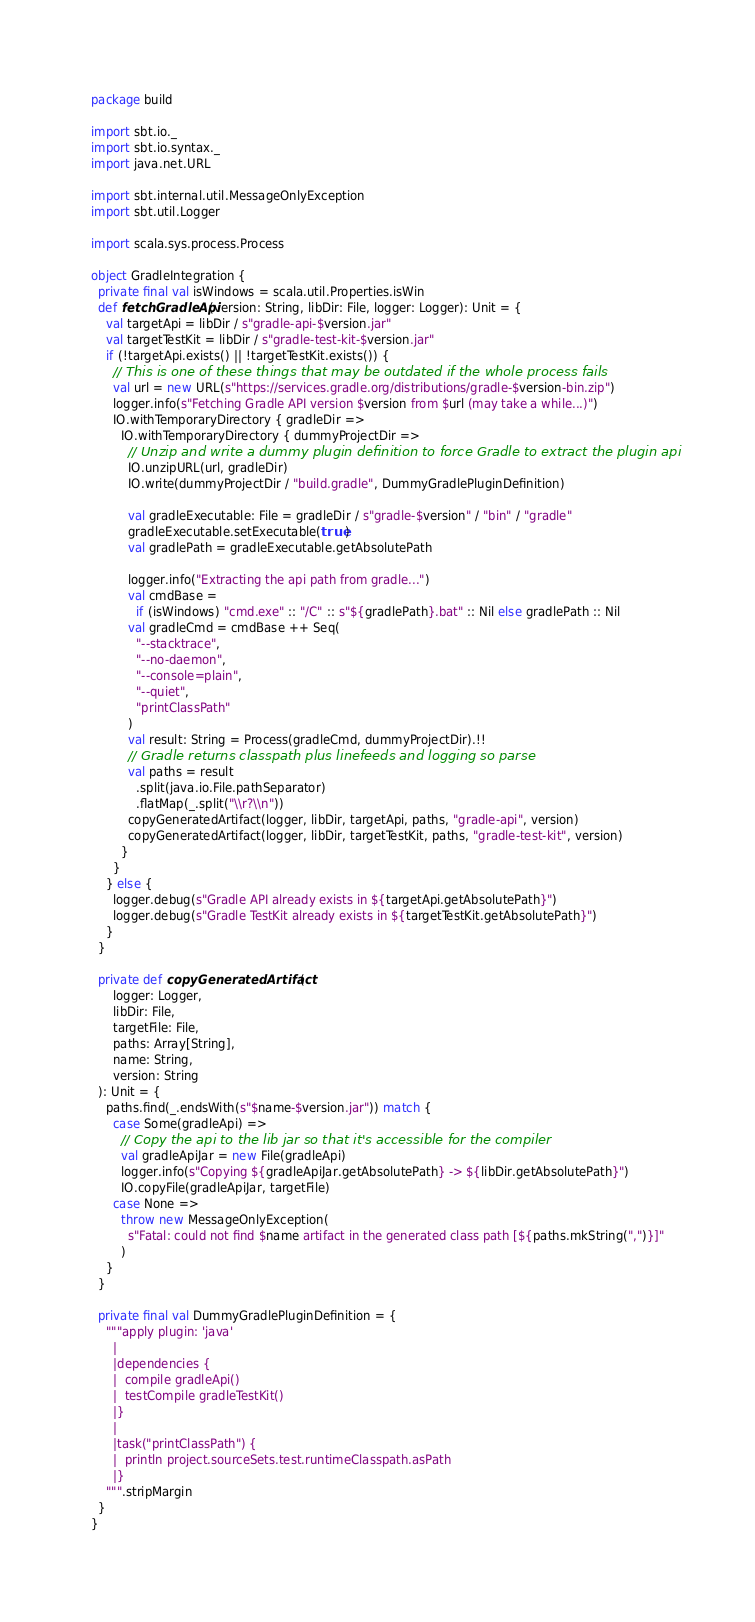Convert code to text. <code><loc_0><loc_0><loc_500><loc_500><_Scala_>package build

import sbt.io._
import sbt.io.syntax._
import java.net.URL

import sbt.internal.util.MessageOnlyException
import sbt.util.Logger

import scala.sys.process.Process

object GradleIntegration {
  private final val isWindows = scala.util.Properties.isWin
  def fetchGradleApi(version: String, libDir: File, logger: Logger): Unit = {
    val targetApi = libDir / s"gradle-api-$version.jar"
    val targetTestKit = libDir / s"gradle-test-kit-$version.jar"
    if (!targetApi.exists() || !targetTestKit.exists()) {
      // This is one of these things that may be outdated if the whole process fails
      val url = new URL(s"https://services.gradle.org/distributions/gradle-$version-bin.zip")
      logger.info(s"Fetching Gradle API version $version from $url (may take a while...)")
      IO.withTemporaryDirectory { gradleDir =>
        IO.withTemporaryDirectory { dummyProjectDir =>
          // Unzip and write a dummy plugin definition to force Gradle to extract the plugin api
          IO.unzipURL(url, gradleDir)
          IO.write(dummyProjectDir / "build.gradle", DummyGradlePluginDefinition)

          val gradleExecutable: File = gradleDir / s"gradle-$version" / "bin" / "gradle"
          gradleExecutable.setExecutable(true)
          val gradlePath = gradleExecutable.getAbsolutePath

          logger.info("Extracting the api path from gradle...")
          val cmdBase =
            if (isWindows) "cmd.exe" :: "/C" :: s"${gradlePath}.bat" :: Nil else gradlePath :: Nil
          val gradleCmd = cmdBase ++ Seq(
            "--stacktrace",
            "--no-daemon",
            "--console=plain",
            "--quiet",
            "printClassPath"
          )
          val result: String = Process(gradleCmd, dummyProjectDir).!!
          // Gradle returns classpath plus linefeeds and logging so parse
          val paths = result
            .split(java.io.File.pathSeparator)
            .flatMap(_.split("\\r?\\n"))
          copyGeneratedArtifact(logger, libDir, targetApi, paths, "gradle-api", version)
          copyGeneratedArtifact(logger, libDir, targetTestKit, paths, "gradle-test-kit", version)
        }
      }
    } else {
      logger.debug(s"Gradle API already exists in ${targetApi.getAbsolutePath}")
      logger.debug(s"Gradle TestKit already exists in ${targetTestKit.getAbsolutePath}")
    }
  }

  private def copyGeneratedArtifact(
      logger: Logger,
      libDir: File,
      targetFile: File,
      paths: Array[String],
      name: String,
      version: String
  ): Unit = {
    paths.find(_.endsWith(s"$name-$version.jar")) match {
      case Some(gradleApi) =>
        // Copy the api to the lib jar so that it's accessible for the compiler
        val gradleApiJar = new File(gradleApi)
        logger.info(s"Copying ${gradleApiJar.getAbsolutePath} -> ${libDir.getAbsolutePath}")
        IO.copyFile(gradleApiJar, targetFile)
      case None =>
        throw new MessageOnlyException(
          s"Fatal: could not find $name artifact in the generated class path [${paths.mkString(",")}]"
        )
    }
  }

  private final val DummyGradlePluginDefinition = {
    """apply plugin: 'java'
      |
      |dependencies {
      |  compile gradleApi()
      |  testCompile gradleTestKit()
      |}
      |
      |task("printClassPath") {
      |  println project.sourceSets.test.runtimeClasspath.asPath
      |}
    """.stripMargin
  }
}
</code> 